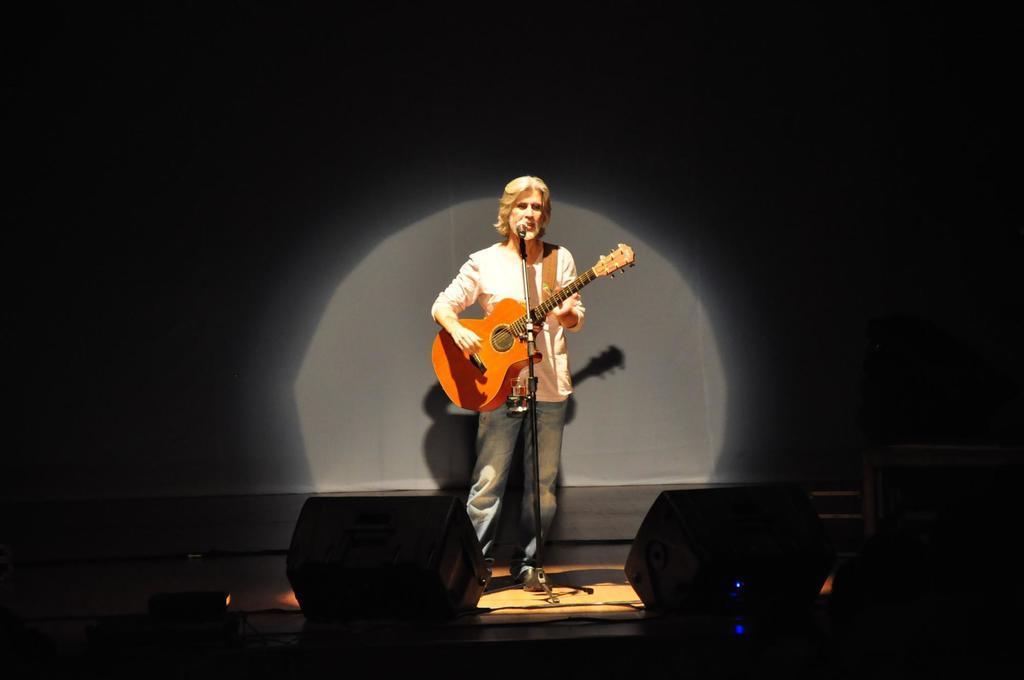Can you describe this image briefly? there is a person playing guitar with the microphone in front of him 